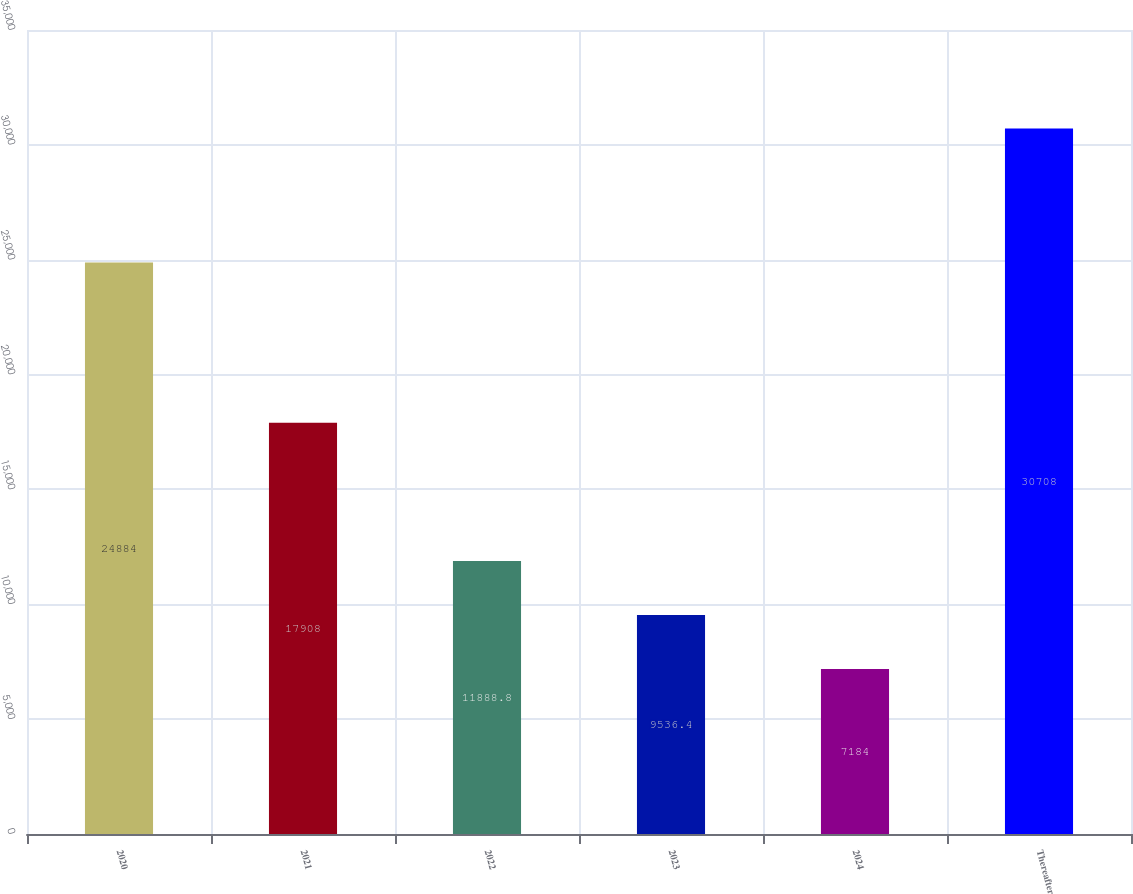<chart> <loc_0><loc_0><loc_500><loc_500><bar_chart><fcel>2020<fcel>2021<fcel>2022<fcel>2023<fcel>2024<fcel>Thereafter<nl><fcel>24884<fcel>17908<fcel>11888.8<fcel>9536.4<fcel>7184<fcel>30708<nl></chart> 